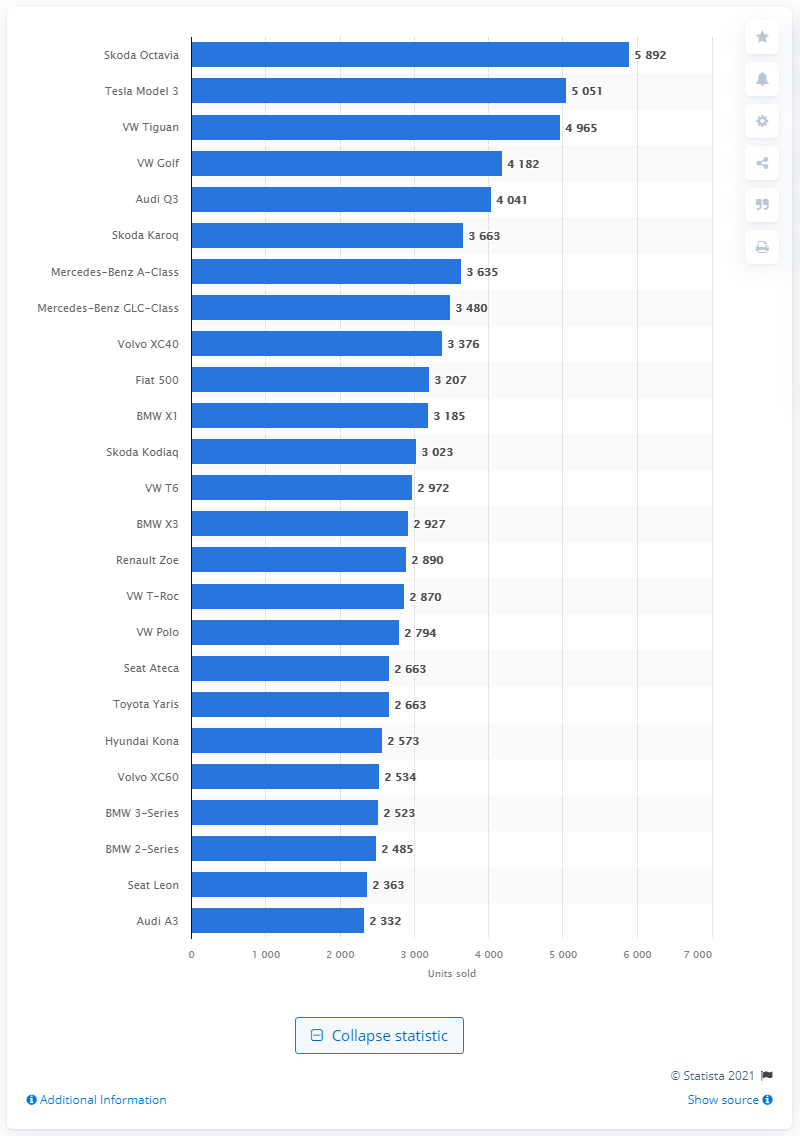List a handful of essential elements in this visual. According to official records, the Skoda Octavia was the car model with the highest number of sales in Switzerland in 2020. 